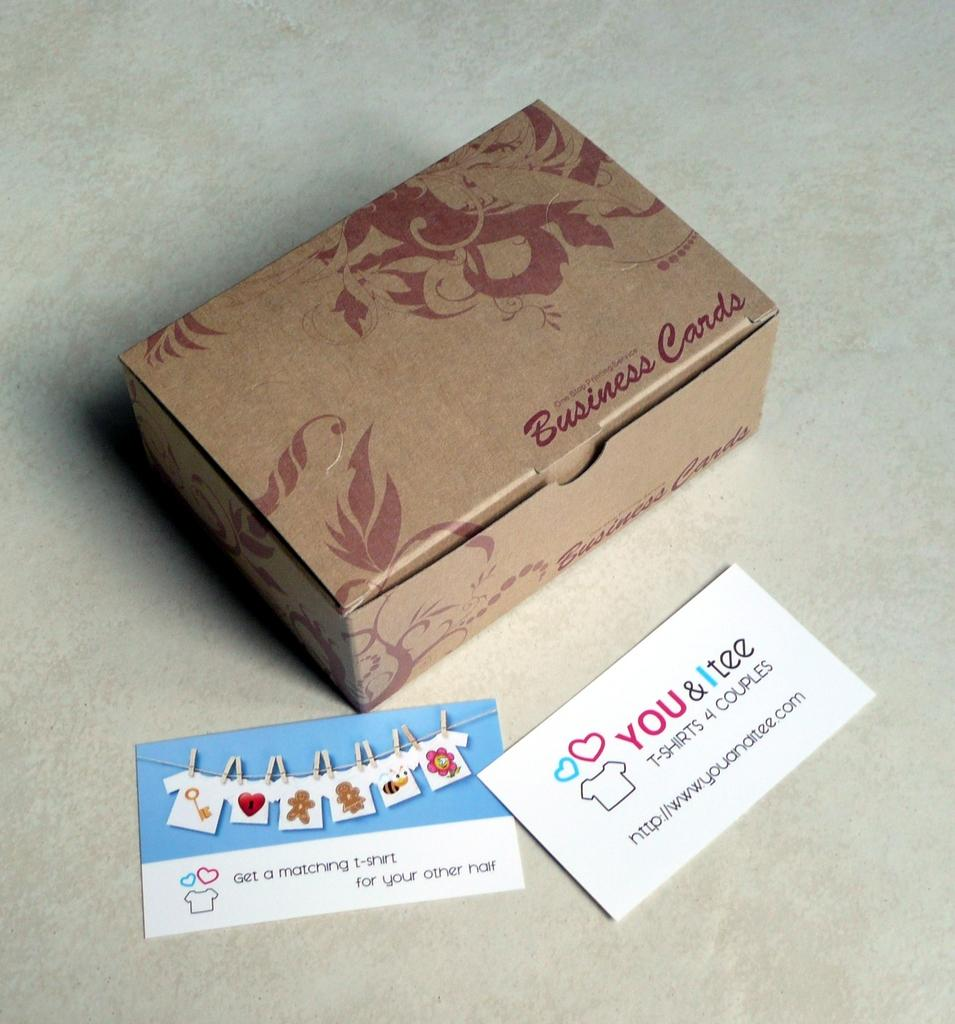<image>
Summarize the visual content of the image. A business card box with two business cards laying in front of it. 